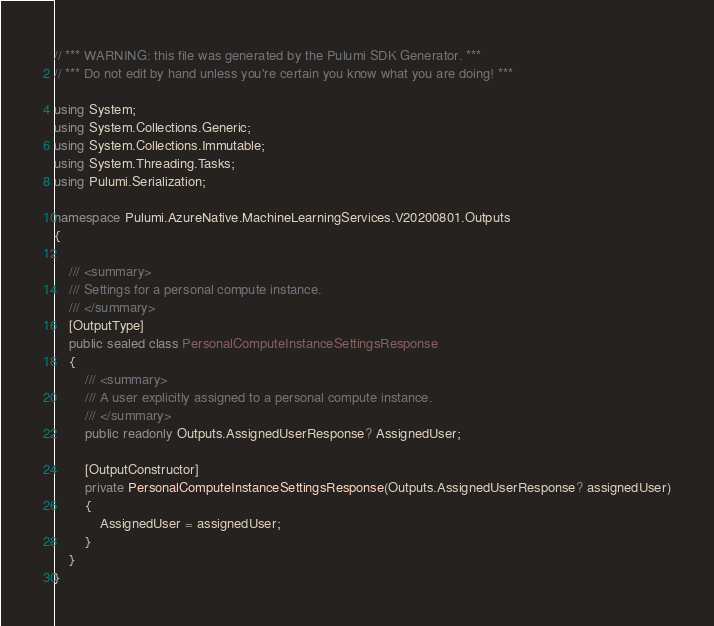Convert code to text. <code><loc_0><loc_0><loc_500><loc_500><_C#_>// *** WARNING: this file was generated by the Pulumi SDK Generator. ***
// *** Do not edit by hand unless you're certain you know what you are doing! ***

using System;
using System.Collections.Generic;
using System.Collections.Immutable;
using System.Threading.Tasks;
using Pulumi.Serialization;

namespace Pulumi.AzureNative.MachineLearningServices.V20200801.Outputs
{

    /// <summary>
    /// Settings for a personal compute instance.
    /// </summary>
    [OutputType]
    public sealed class PersonalComputeInstanceSettingsResponse
    {
        /// <summary>
        /// A user explicitly assigned to a personal compute instance.
        /// </summary>
        public readonly Outputs.AssignedUserResponse? AssignedUser;

        [OutputConstructor]
        private PersonalComputeInstanceSettingsResponse(Outputs.AssignedUserResponse? assignedUser)
        {
            AssignedUser = assignedUser;
        }
    }
}
</code> 